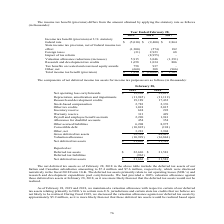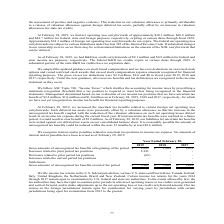According to Calamp's financial document, What does the deferred tax assets primarily relate to? net operating losses (NOL’s) and research and development expenditure pool carryforwards. The document states: "10-K. The deferred tax assets primarily relate to net operating losses (NOL’s) and research and development expenditure pool carryforwards. We had pro..." Also, What was the Inventory Reserve in 2019? According to the financial document, 624 (in thousands). The relevant text states: "6 Other tax credits 1,018 2,015 Inventory reserve 624 292 Warranty reserve 313 429 Payroll and employee benefit accruals 2,220 1,941 Allowance for doubtf..." Also, What was the Warranty Reserve in 2019? According to the financial document, 313 (in thousands). The relevant text states: "2,015 Inventory reserve 624 292 Warranty reserve 313 429 Payroll and employee benefit accruals 2,220 1,941 Allowance for doubtful accounts 454 354 Other..." Also, can you calculate: What was the percentage change in Inventory Reserve between 2018 to 2019? To answer this question, I need to perform calculations using the financial data. The calculation is: (624-292)/292, which equals 113.7 (percentage). This is based on the information: "6 Other tax credits 1,018 2,015 Inventory reserve 624 292 Warranty reserve 313 429 Payroll and employee benefit accruals 2,220 1,941 Allowance for doubtf her tax credits 1,018 2,015 Inventory reserve ..." The key data points involved are: 292, 624. Also, can you calculate: What was the percentage change in Allowance for doubtful accounts between 2018 to 2019? To answer this question, I need to perform calculations using the financial data. The calculation is: (454-354)/354, which equals 28.25 (percentage). This is based on the information: "ruals 2,220 1,941 Allowance for doubtful accounts 454 354 Other accrued liabilities 6,208 8,975 Convertible debt (10,822) (194) Other, net 3,281 3,904 Gr s 2,220 1,941 Allowance for doubtful accounts ..." The key data points involved are: 354, 454. Also, can you calculate: How much do the top 3 components add up to? Based on the calculation: (19,269+19,189+6,208), the result is 44666 (in thousands). This is based on the information: "ubtful accounts 454 354 Other accrued liabilities 6,208 8,975 Convertible debt (10,822) (194) Other, net 3,281 3,904 Gross deferred tax assets 32,592 48,42 28, 2019 2018 Net operating loss carryforwar..." The key data points involved are: 19,189, 19,269, 6,208. 